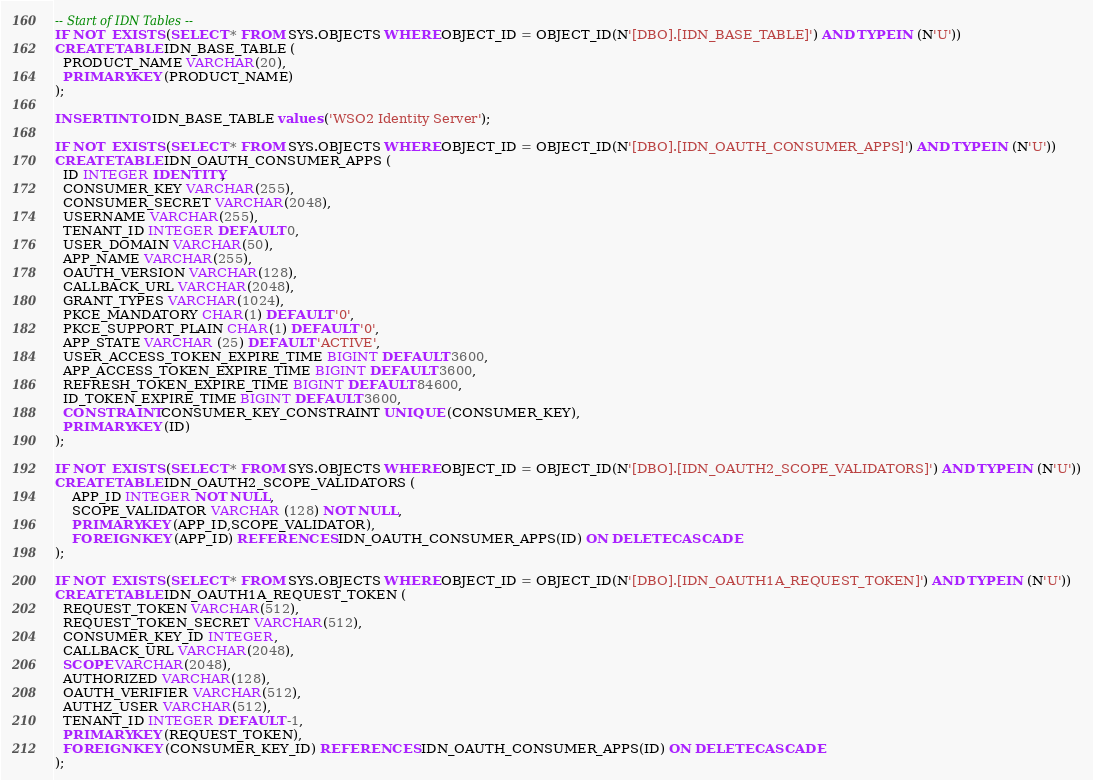Convert code to text. <code><loc_0><loc_0><loc_500><loc_500><_SQL_>-- Start of IDN Tables --
IF NOT  EXISTS (SELECT * FROM SYS.OBJECTS WHERE OBJECT_ID = OBJECT_ID(N'[DBO].[IDN_BASE_TABLE]') AND TYPE IN (N'U'))
CREATE TABLE IDN_BASE_TABLE (
  PRODUCT_NAME VARCHAR(20),
  PRIMARY KEY (PRODUCT_NAME)
);

INSERT INTO IDN_BASE_TABLE values ('WSO2 Identity Server');

IF NOT  EXISTS (SELECT * FROM SYS.OBJECTS WHERE OBJECT_ID = OBJECT_ID(N'[DBO].[IDN_OAUTH_CONSUMER_APPS]') AND TYPE IN (N'U'))
CREATE TABLE IDN_OAUTH_CONSUMER_APPS (
  ID INTEGER IDENTITY,
  CONSUMER_KEY VARCHAR(255),
  CONSUMER_SECRET VARCHAR(2048),
  USERNAME VARCHAR(255),
  TENANT_ID INTEGER DEFAULT 0,
  USER_DOMAIN VARCHAR(50),
  APP_NAME VARCHAR(255),
  OAUTH_VERSION VARCHAR(128),
  CALLBACK_URL VARCHAR(2048),
  GRANT_TYPES VARCHAR(1024),
  PKCE_MANDATORY CHAR(1) DEFAULT '0',
  PKCE_SUPPORT_PLAIN CHAR(1) DEFAULT '0',
  APP_STATE VARCHAR (25) DEFAULT 'ACTIVE',
  USER_ACCESS_TOKEN_EXPIRE_TIME BIGINT DEFAULT 3600,
  APP_ACCESS_TOKEN_EXPIRE_TIME BIGINT DEFAULT 3600,
  REFRESH_TOKEN_EXPIRE_TIME BIGINT DEFAULT 84600,
  ID_TOKEN_EXPIRE_TIME BIGINT DEFAULT 3600,
  CONSTRAINT CONSUMER_KEY_CONSTRAINT UNIQUE (CONSUMER_KEY),
  PRIMARY KEY (ID)
);

IF NOT  EXISTS (SELECT * FROM SYS.OBJECTS WHERE OBJECT_ID = OBJECT_ID(N'[DBO].[IDN_OAUTH2_SCOPE_VALIDATORS]') AND TYPE IN (N'U'))
CREATE TABLE IDN_OAUTH2_SCOPE_VALIDATORS (
	APP_ID INTEGER NOT NULL,
	SCOPE_VALIDATOR VARCHAR (128) NOT NULL,
	PRIMARY KEY (APP_ID,SCOPE_VALIDATOR),
	FOREIGN KEY (APP_ID) REFERENCES IDN_OAUTH_CONSUMER_APPS(ID) ON DELETE CASCADE
);

IF NOT  EXISTS (SELECT * FROM SYS.OBJECTS WHERE OBJECT_ID = OBJECT_ID(N'[DBO].[IDN_OAUTH1A_REQUEST_TOKEN]') AND TYPE IN (N'U'))
CREATE TABLE IDN_OAUTH1A_REQUEST_TOKEN (
  REQUEST_TOKEN VARCHAR(512),
  REQUEST_TOKEN_SECRET VARCHAR(512),
  CONSUMER_KEY_ID INTEGER,
  CALLBACK_URL VARCHAR(2048),
  SCOPE VARCHAR(2048),
  AUTHORIZED VARCHAR(128),
  OAUTH_VERIFIER VARCHAR(512),
  AUTHZ_USER VARCHAR(512),
  TENANT_ID INTEGER DEFAULT -1,
  PRIMARY KEY (REQUEST_TOKEN),
  FOREIGN KEY (CONSUMER_KEY_ID) REFERENCES IDN_OAUTH_CONSUMER_APPS(ID) ON DELETE CASCADE
);
</code> 